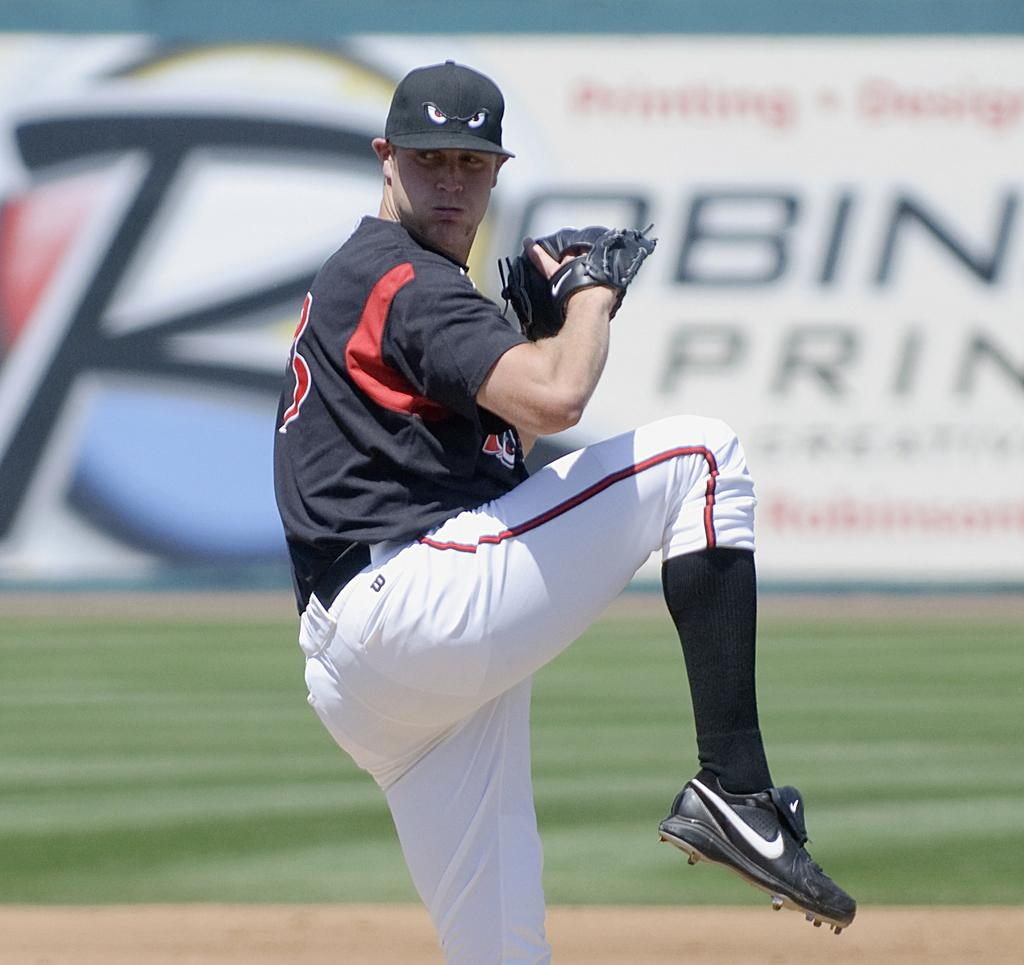<image>
Create a compact narrative representing the image presented. A pitcher about to throw a ball in front of an ad for Robin printing. 